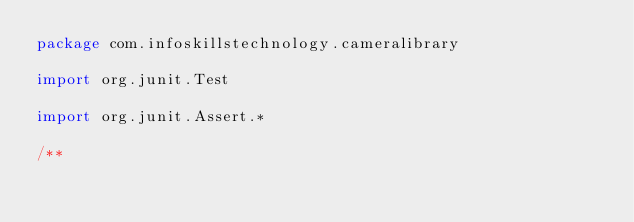<code> <loc_0><loc_0><loc_500><loc_500><_Kotlin_>package com.infoskillstechnology.cameralibrary

import org.junit.Test

import org.junit.Assert.*

/**</code> 